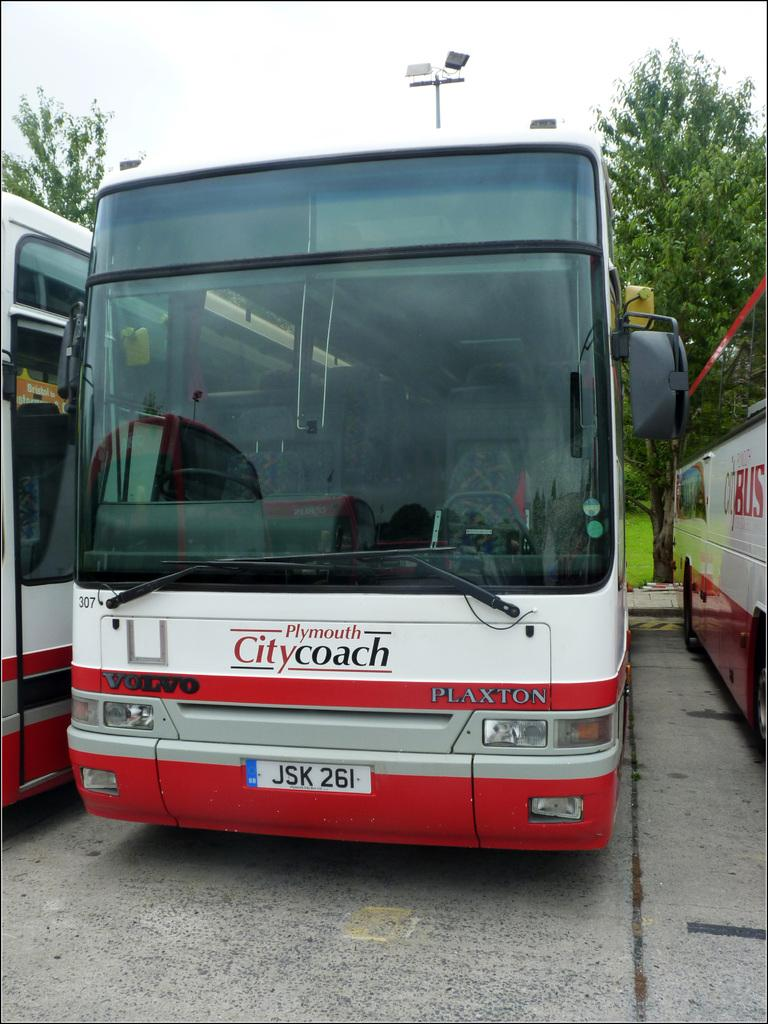What type of vehicles can be seen on the road in the image? There are buses on the road in the image. What objects are visible on the buses? Glass objects are visible on the buses. What type of information is displayed on the buses? Numbers and text are present on the buses. What can be seen in the background of the image? There are lights and trees in the background of the image. Can you tell me what type of stew is being served on the buses in the image? There is no stew present in the image; the focus is on the buses and their features. 